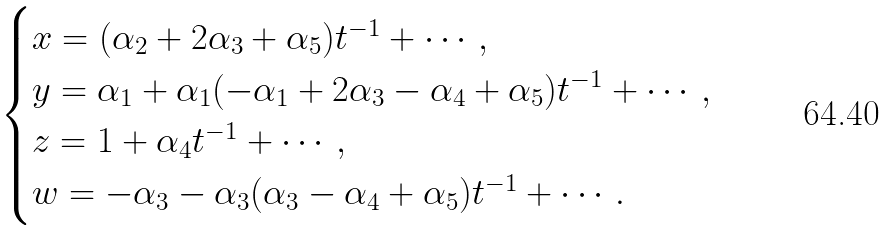Convert formula to latex. <formula><loc_0><loc_0><loc_500><loc_500>\begin{cases} x = ( \alpha _ { 2 } + 2 \alpha _ { 3 } + \alpha _ { 5 } ) t ^ { - 1 } + \cdots , \\ y = \alpha _ { 1 } + \alpha _ { 1 } ( - \alpha _ { 1 } + 2 \alpha _ { 3 } - \alpha _ { 4 } + \alpha _ { 5 } ) t ^ { - 1 } + \cdots , \\ z = 1 + \alpha _ { 4 } t ^ { - 1 } + \cdots , \\ w = - \alpha _ { 3 } - \alpha _ { 3 } ( \alpha _ { 3 } - \alpha _ { 4 } + \alpha _ { 5 } ) t ^ { - 1 } + \cdots . \end{cases}</formula> 